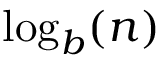Convert formula to latex. <formula><loc_0><loc_0><loc_500><loc_500>\log _ { b } ( n )</formula> 